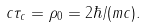Convert formula to latex. <formula><loc_0><loc_0><loc_500><loc_500>c \tau _ { c } = \rho _ { 0 } = 2 \hbar { / } ( m c ) .</formula> 